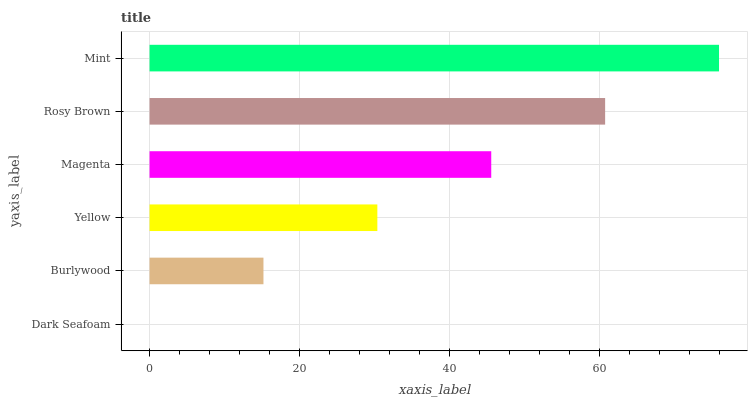Is Dark Seafoam the minimum?
Answer yes or no. Yes. Is Mint the maximum?
Answer yes or no. Yes. Is Burlywood the minimum?
Answer yes or no. No. Is Burlywood the maximum?
Answer yes or no. No. Is Burlywood greater than Dark Seafoam?
Answer yes or no. Yes. Is Dark Seafoam less than Burlywood?
Answer yes or no. Yes. Is Dark Seafoam greater than Burlywood?
Answer yes or no. No. Is Burlywood less than Dark Seafoam?
Answer yes or no. No. Is Magenta the high median?
Answer yes or no. Yes. Is Yellow the low median?
Answer yes or no. Yes. Is Mint the high median?
Answer yes or no. No. Is Burlywood the low median?
Answer yes or no. No. 